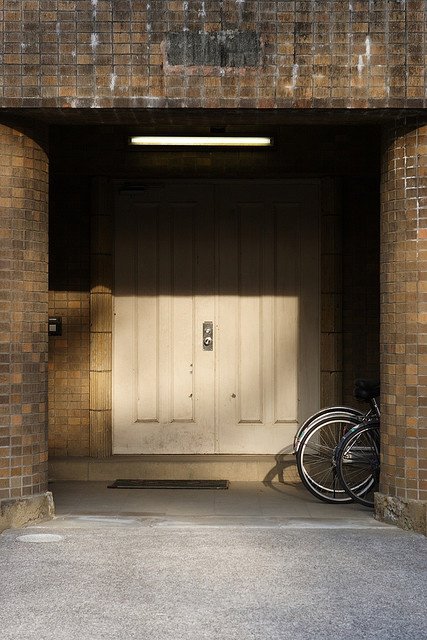Describe the objects in this image and their specific colors. I can see a bicycle in gray and black tones in this image. 